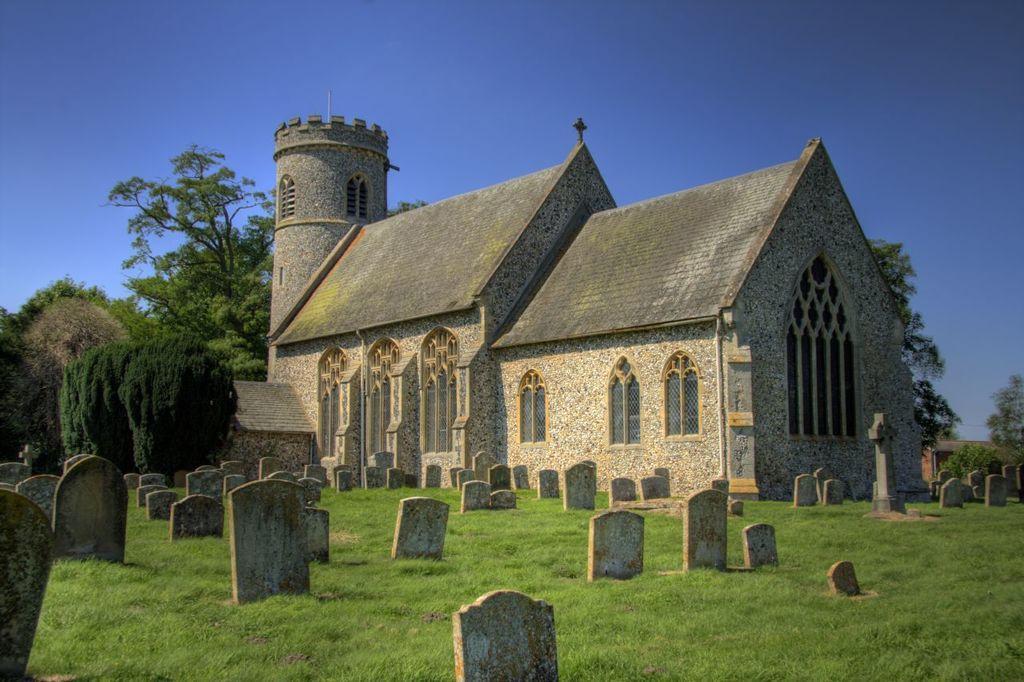In one or two sentences, can you explain what this image depicts? In this picture we can see a brown color church with shed tiles. In the front side there is a graveyard with many stone and cross marks. Behind there are some trees. 